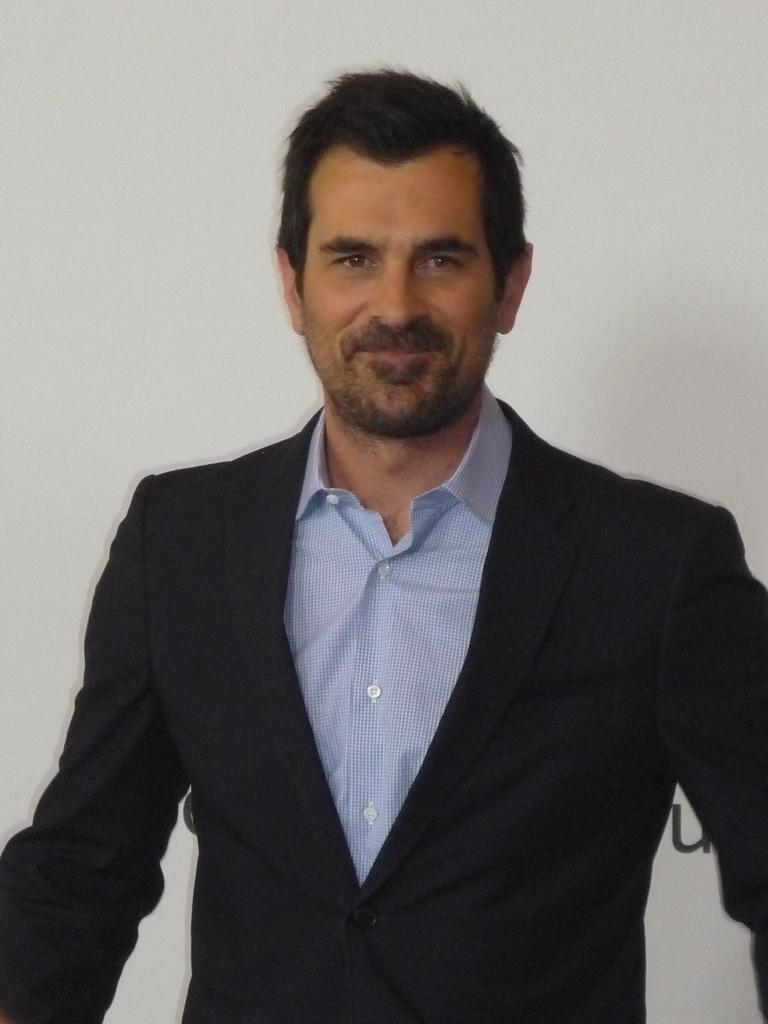Who is present in the image? There is a man in the image. What is the man doing in the image? The man is smiling in the image. What is the man wearing in the image? The man is wearing a blazer in the image. What can be seen in the background of the image? There is a wall in the background of the image. What game is the man playing in the image? There is no game present in the image; it only features a man who is smiling and wearing a blazer. 